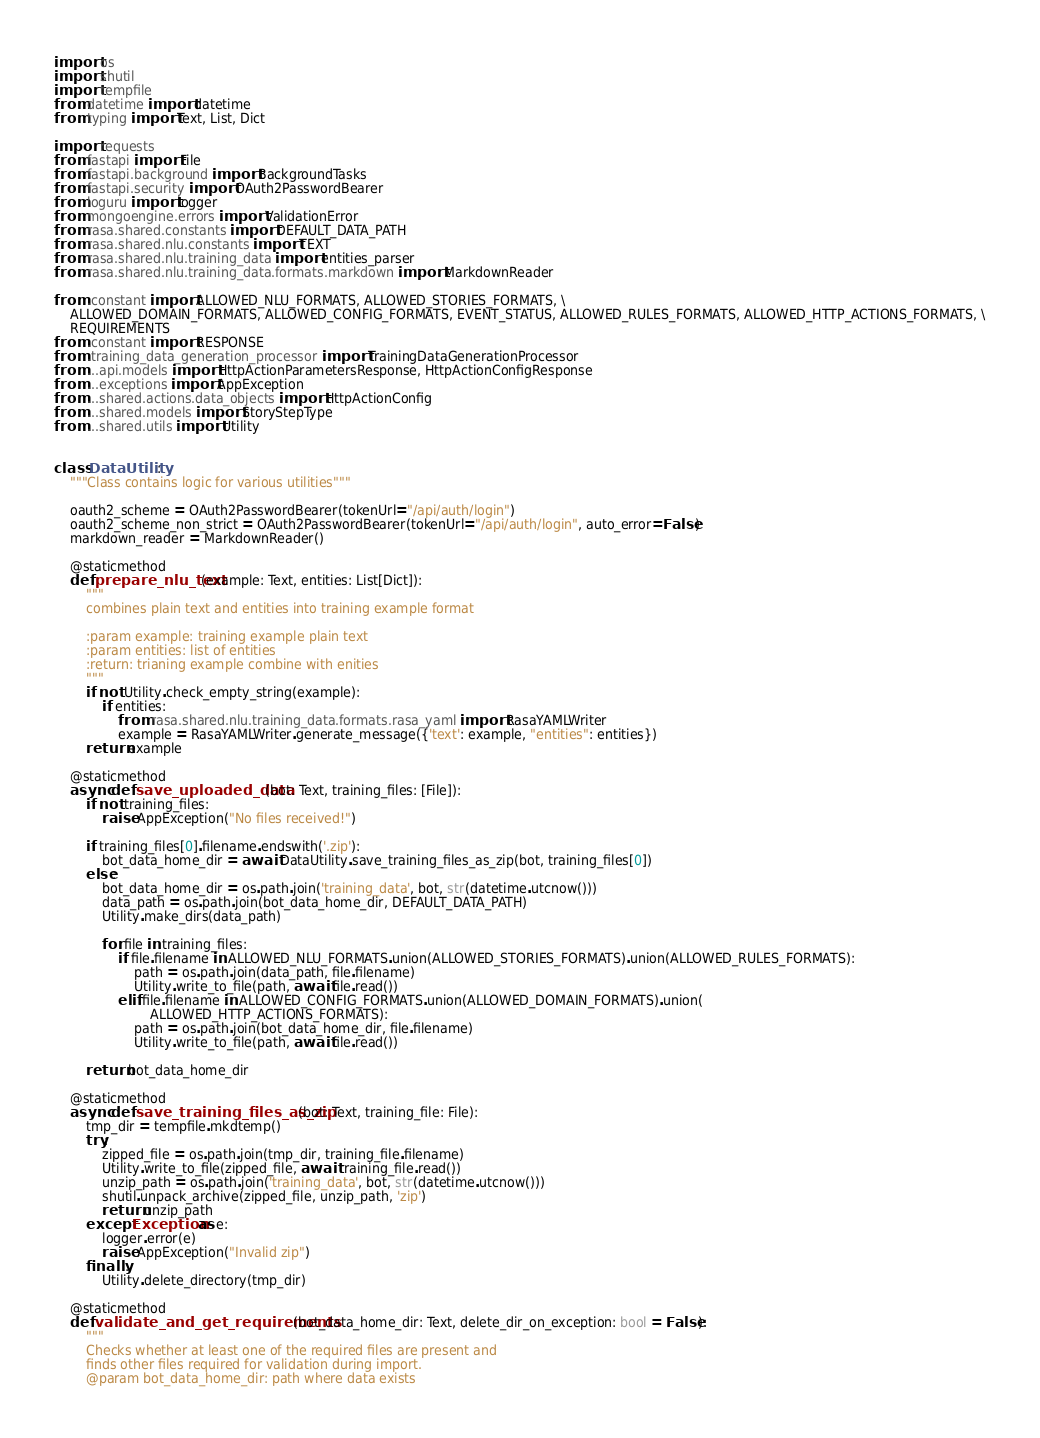Convert code to text. <code><loc_0><loc_0><loc_500><loc_500><_Python_>import os
import shutil
import tempfile
from datetime import datetime
from typing import Text, List, Dict

import requests
from fastapi import File
from fastapi.background import BackgroundTasks
from fastapi.security import OAuth2PasswordBearer
from loguru import logger
from mongoengine.errors import ValidationError
from rasa.shared.constants import DEFAULT_DATA_PATH
from rasa.shared.nlu.constants import TEXT
from rasa.shared.nlu.training_data import entities_parser
from rasa.shared.nlu.training_data.formats.markdown import MarkdownReader

from .constant import ALLOWED_NLU_FORMATS, ALLOWED_STORIES_FORMATS, \
    ALLOWED_DOMAIN_FORMATS, ALLOWED_CONFIG_FORMATS, EVENT_STATUS, ALLOWED_RULES_FORMATS, ALLOWED_HTTP_ACTIONS_FORMATS, \
    REQUIREMENTS
from .constant import RESPONSE
from .training_data_generation_processor import TrainingDataGenerationProcessor
from ...api.models import HttpActionParametersResponse, HttpActionConfigResponse
from ...exceptions import AppException
from ...shared.actions.data_objects import HttpActionConfig
from ...shared.models import StoryStepType
from ...shared.utils import Utility


class DataUtility:
    """Class contains logic for various utilities"""

    oauth2_scheme = OAuth2PasswordBearer(tokenUrl="/api/auth/login")
    oauth2_scheme_non_strict = OAuth2PasswordBearer(tokenUrl="/api/auth/login", auto_error=False)
    markdown_reader = MarkdownReader()

    @staticmethod
    def prepare_nlu_text(example: Text, entities: List[Dict]):
        """
        combines plain text and entities into training example format

        :param example: training example plain text
        :param entities: list of entities
        :return: trianing example combine with enities
        """
        if not Utility.check_empty_string(example):
            if entities:
                from rasa.shared.nlu.training_data.formats.rasa_yaml import RasaYAMLWriter
                example = RasaYAMLWriter.generate_message({'text': example, "entities": entities})
        return example

    @staticmethod
    async def save_uploaded_data(bot: Text, training_files: [File]):
        if not training_files:
            raise AppException("No files received!")

        if training_files[0].filename.endswith('.zip'):
            bot_data_home_dir = await DataUtility.save_training_files_as_zip(bot, training_files[0])
        else:
            bot_data_home_dir = os.path.join('training_data', bot, str(datetime.utcnow()))
            data_path = os.path.join(bot_data_home_dir, DEFAULT_DATA_PATH)
            Utility.make_dirs(data_path)

            for file in training_files:
                if file.filename in ALLOWED_NLU_FORMATS.union(ALLOWED_STORIES_FORMATS).union(ALLOWED_RULES_FORMATS):
                    path = os.path.join(data_path, file.filename)
                    Utility.write_to_file(path, await file.read())
                elif file.filename in ALLOWED_CONFIG_FORMATS.union(ALLOWED_DOMAIN_FORMATS).union(
                        ALLOWED_HTTP_ACTIONS_FORMATS):
                    path = os.path.join(bot_data_home_dir, file.filename)
                    Utility.write_to_file(path, await file.read())

        return bot_data_home_dir

    @staticmethod
    async def save_training_files_as_zip(bot: Text, training_file: File):
        tmp_dir = tempfile.mkdtemp()
        try:
            zipped_file = os.path.join(tmp_dir, training_file.filename)
            Utility.write_to_file(zipped_file, await training_file.read())
            unzip_path = os.path.join('training_data', bot, str(datetime.utcnow()))
            shutil.unpack_archive(zipped_file, unzip_path, 'zip')
            return unzip_path
        except Exception as e:
            logger.error(e)
            raise AppException("Invalid zip")
        finally:
            Utility.delete_directory(tmp_dir)

    @staticmethod
    def validate_and_get_requirements(bot_data_home_dir: Text, delete_dir_on_exception: bool = False):
        """
        Checks whether at least one of the required files are present and
        finds other files required for validation during import.
        @param bot_data_home_dir: path where data exists</code> 